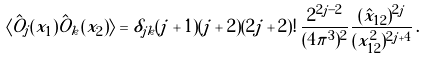Convert formula to latex. <formula><loc_0><loc_0><loc_500><loc_500>\langle \hat { O } _ { j } ( x _ { 1 } ) \hat { O } _ { k } ( x _ { 2 } ) \rangle = \delta _ { j k } ( j + 1 ) ( j + 2 ) ( 2 j + 2 ) ! \, \frac { 2 ^ { 2 j - 2 } } { ( 4 \pi ^ { 3 } ) ^ { 2 } } \frac { ( \hat { x } _ { 1 2 } ) ^ { 2 j } } { ( x _ { 1 2 } ^ { 2 } ) ^ { 2 j + 4 } } \, .</formula> 